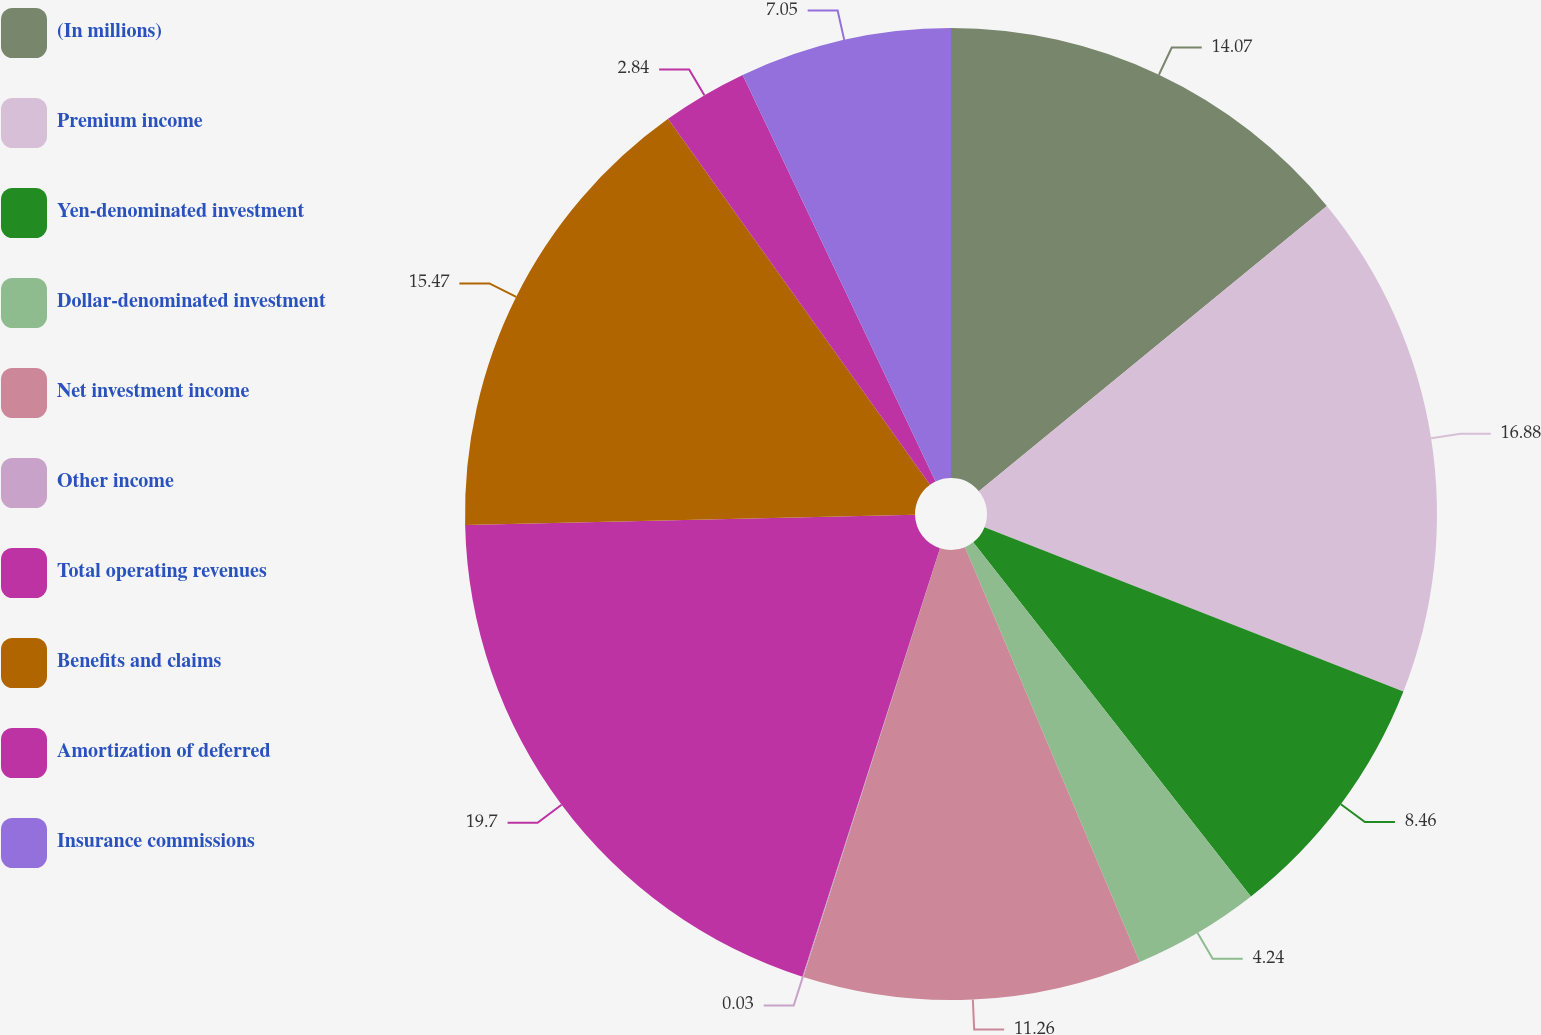Convert chart. <chart><loc_0><loc_0><loc_500><loc_500><pie_chart><fcel>(In millions)<fcel>Premium income<fcel>Yen-denominated investment<fcel>Dollar-denominated investment<fcel>Net investment income<fcel>Other income<fcel>Total operating revenues<fcel>Benefits and claims<fcel>Amortization of deferred<fcel>Insurance commissions<nl><fcel>14.07%<fcel>16.88%<fcel>8.46%<fcel>4.24%<fcel>11.26%<fcel>0.03%<fcel>19.69%<fcel>15.47%<fcel>2.84%<fcel>7.05%<nl></chart> 